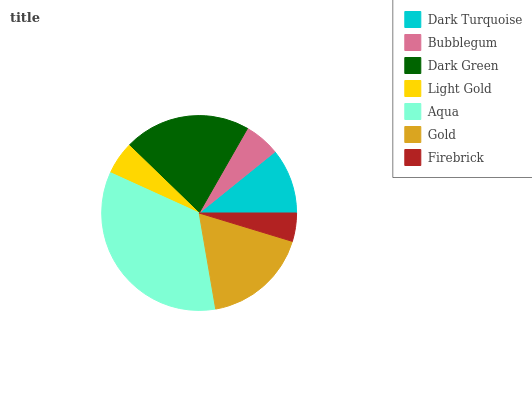Is Firebrick the minimum?
Answer yes or no. Yes. Is Aqua the maximum?
Answer yes or no. Yes. Is Bubblegum the minimum?
Answer yes or no. No. Is Bubblegum the maximum?
Answer yes or no. No. Is Dark Turquoise greater than Bubblegum?
Answer yes or no. Yes. Is Bubblegum less than Dark Turquoise?
Answer yes or no. Yes. Is Bubblegum greater than Dark Turquoise?
Answer yes or no. No. Is Dark Turquoise less than Bubblegum?
Answer yes or no. No. Is Dark Turquoise the high median?
Answer yes or no. Yes. Is Dark Turquoise the low median?
Answer yes or no. Yes. Is Dark Green the high median?
Answer yes or no. No. Is Dark Green the low median?
Answer yes or no. No. 